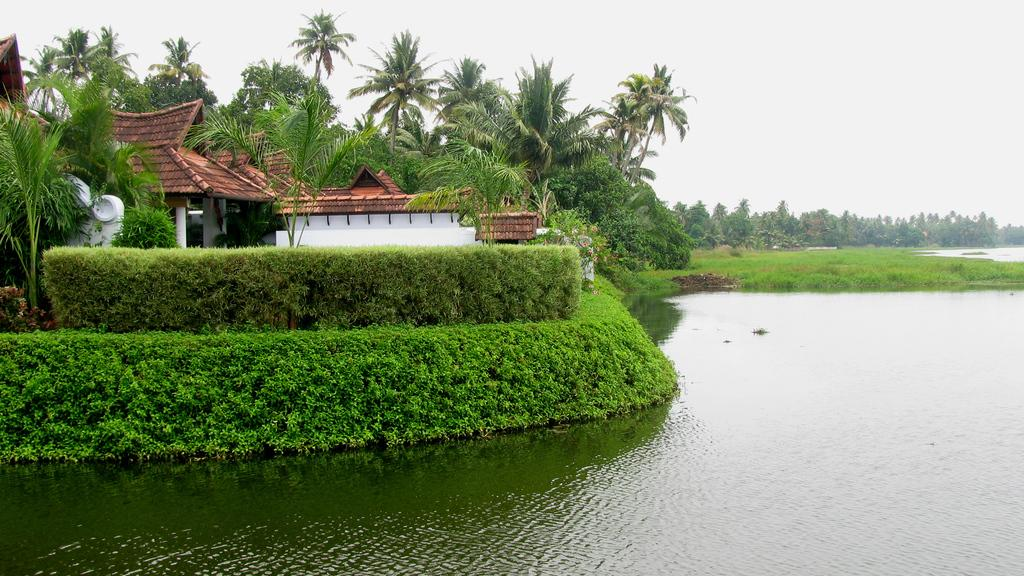What type of structures can be seen in the image? There are houses with roofs and pillars in the image. What natural feature is present in the image? There is a large water body in the image. What type of vegetation is visible in the image? There are plants, a group of trees, and grass present in the image. How would you describe the sky in the image? The sky is visible in the image and appears cloudy. Can you hear the snake crying in the image? There is no snake or crying sound present in the image. What is the heart rate of the trees in the image? Trees do not have hearts or heart rates, so this question cannot be answered. 